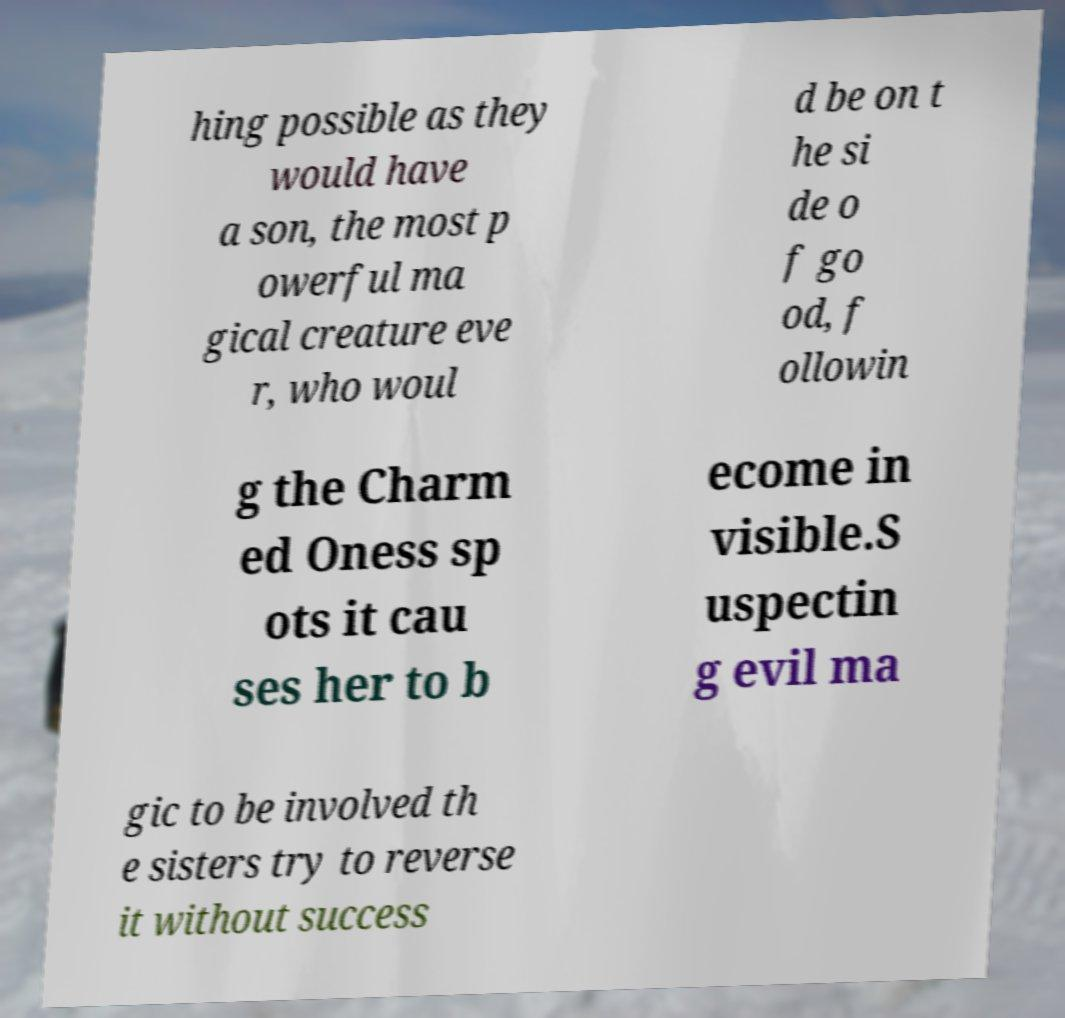For documentation purposes, I need the text within this image transcribed. Could you provide that? hing possible as they would have a son, the most p owerful ma gical creature eve r, who woul d be on t he si de o f go od, f ollowin g the Charm ed Oness sp ots it cau ses her to b ecome in visible.S uspectin g evil ma gic to be involved th e sisters try to reverse it without success 